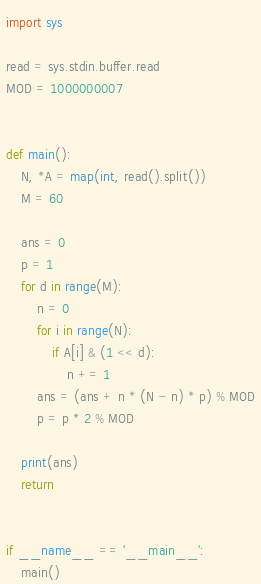Convert code to text. <code><loc_0><loc_0><loc_500><loc_500><_Python_>import sys

read = sys.stdin.buffer.read
MOD = 1000000007


def main():
    N, *A = map(int, read().split())
    M = 60

    ans = 0
    p = 1
    for d in range(M):
        n = 0
        for i in range(N):
            if A[i] & (1 << d):
                n += 1
        ans = (ans + n * (N - n) * p) % MOD
        p = p * 2 % MOD

    print(ans)
    return


if __name__ == '__main__':
    main()
</code> 